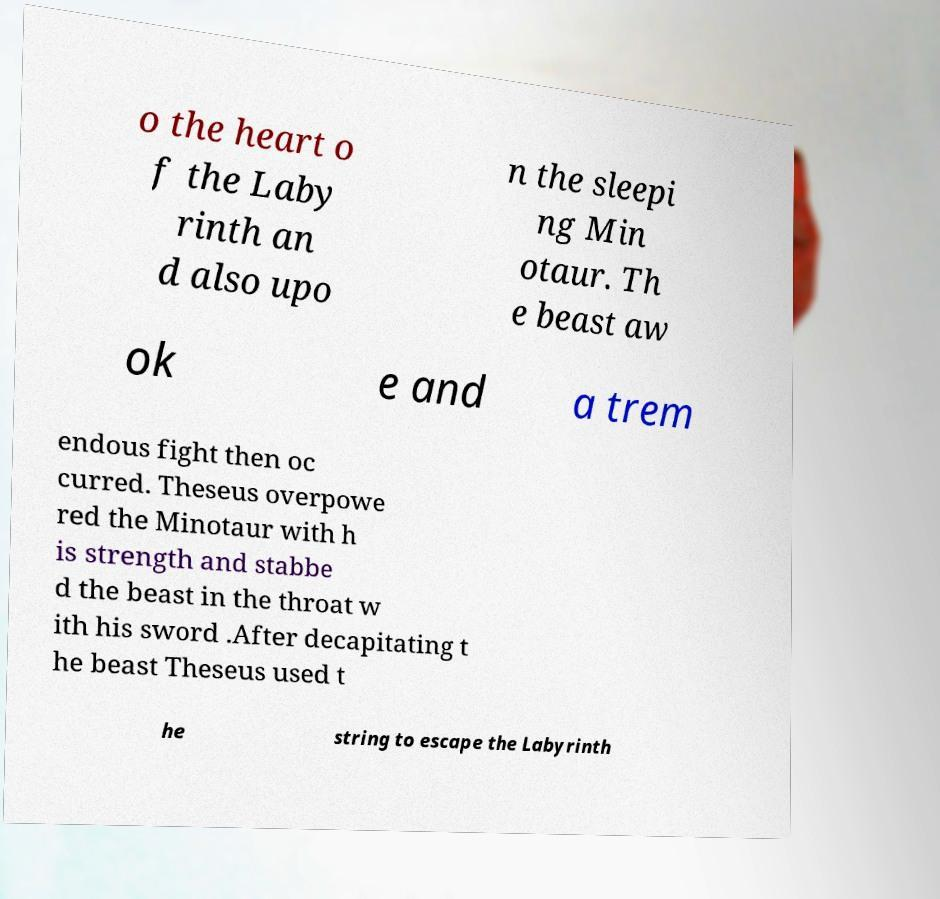What messages or text are displayed in this image? I need them in a readable, typed format. o the heart o f the Laby rinth an d also upo n the sleepi ng Min otaur. Th e beast aw ok e and a trem endous fight then oc curred. Theseus overpowe red the Minotaur with h is strength and stabbe d the beast in the throat w ith his sword .After decapitating t he beast Theseus used t he string to escape the Labyrinth 